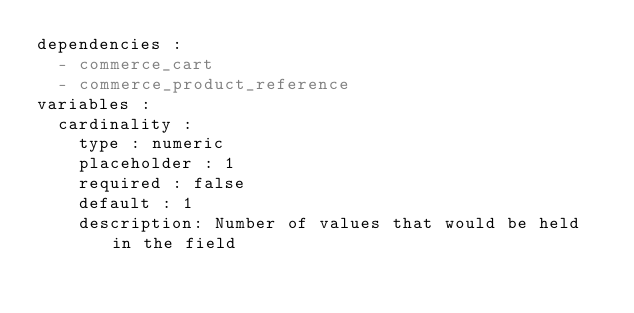Convert code to text. <code><loc_0><loc_0><loc_500><loc_500><_YAML_>dependencies :
  - commerce_cart
  - commerce_product_reference
variables :
  cardinality :
    type : numeric
    placeholder : 1
    required : false
    default : 1
    description: Number of values that would be held in the field</code> 